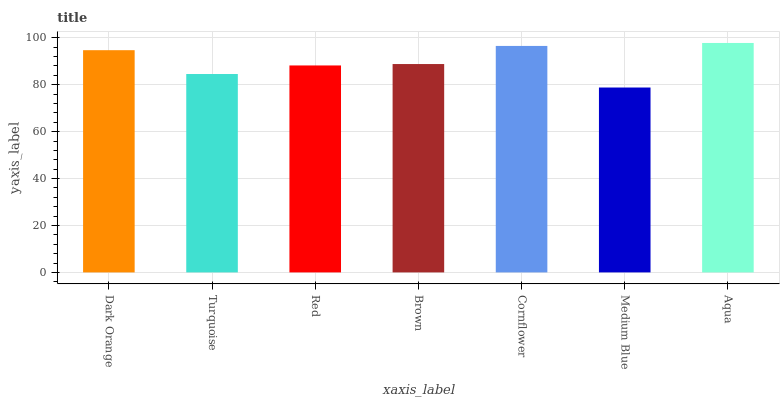Is Medium Blue the minimum?
Answer yes or no. Yes. Is Aqua the maximum?
Answer yes or no. Yes. Is Turquoise the minimum?
Answer yes or no. No. Is Turquoise the maximum?
Answer yes or no. No. Is Dark Orange greater than Turquoise?
Answer yes or no. Yes. Is Turquoise less than Dark Orange?
Answer yes or no. Yes. Is Turquoise greater than Dark Orange?
Answer yes or no. No. Is Dark Orange less than Turquoise?
Answer yes or no. No. Is Brown the high median?
Answer yes or no. Yes. Is Brown the low median?
Answer yes or no. Yes. Is Medium Blue the high median?
Answer yes or no. No. Is Turquoise the low median?
Answer yes or no. No. 